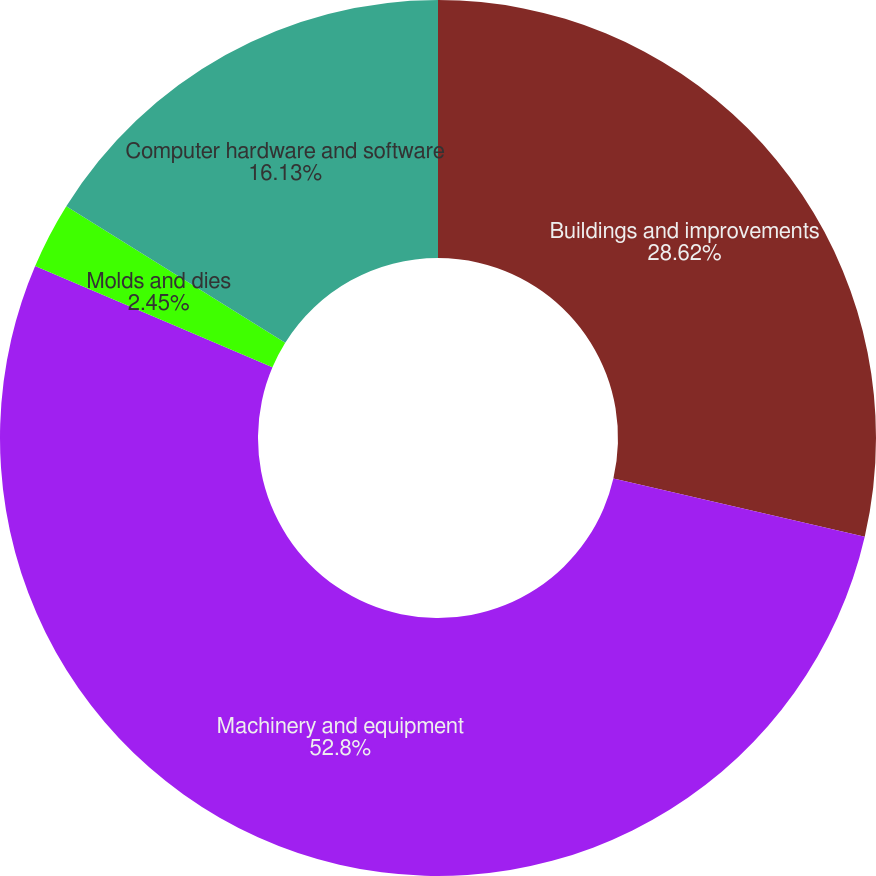<chart> <loc_0><loc_0><loc_500><loc_500><pie_chart><fcel>Buildings and improvements<fcel>Machinery and equipment<fcel>Molds and dies<fcel>Computer hardware and software<nl><fcel>28.62%<fcel>52.81%<fcel>2.45%<fcel>16.13%<nl></chart> 